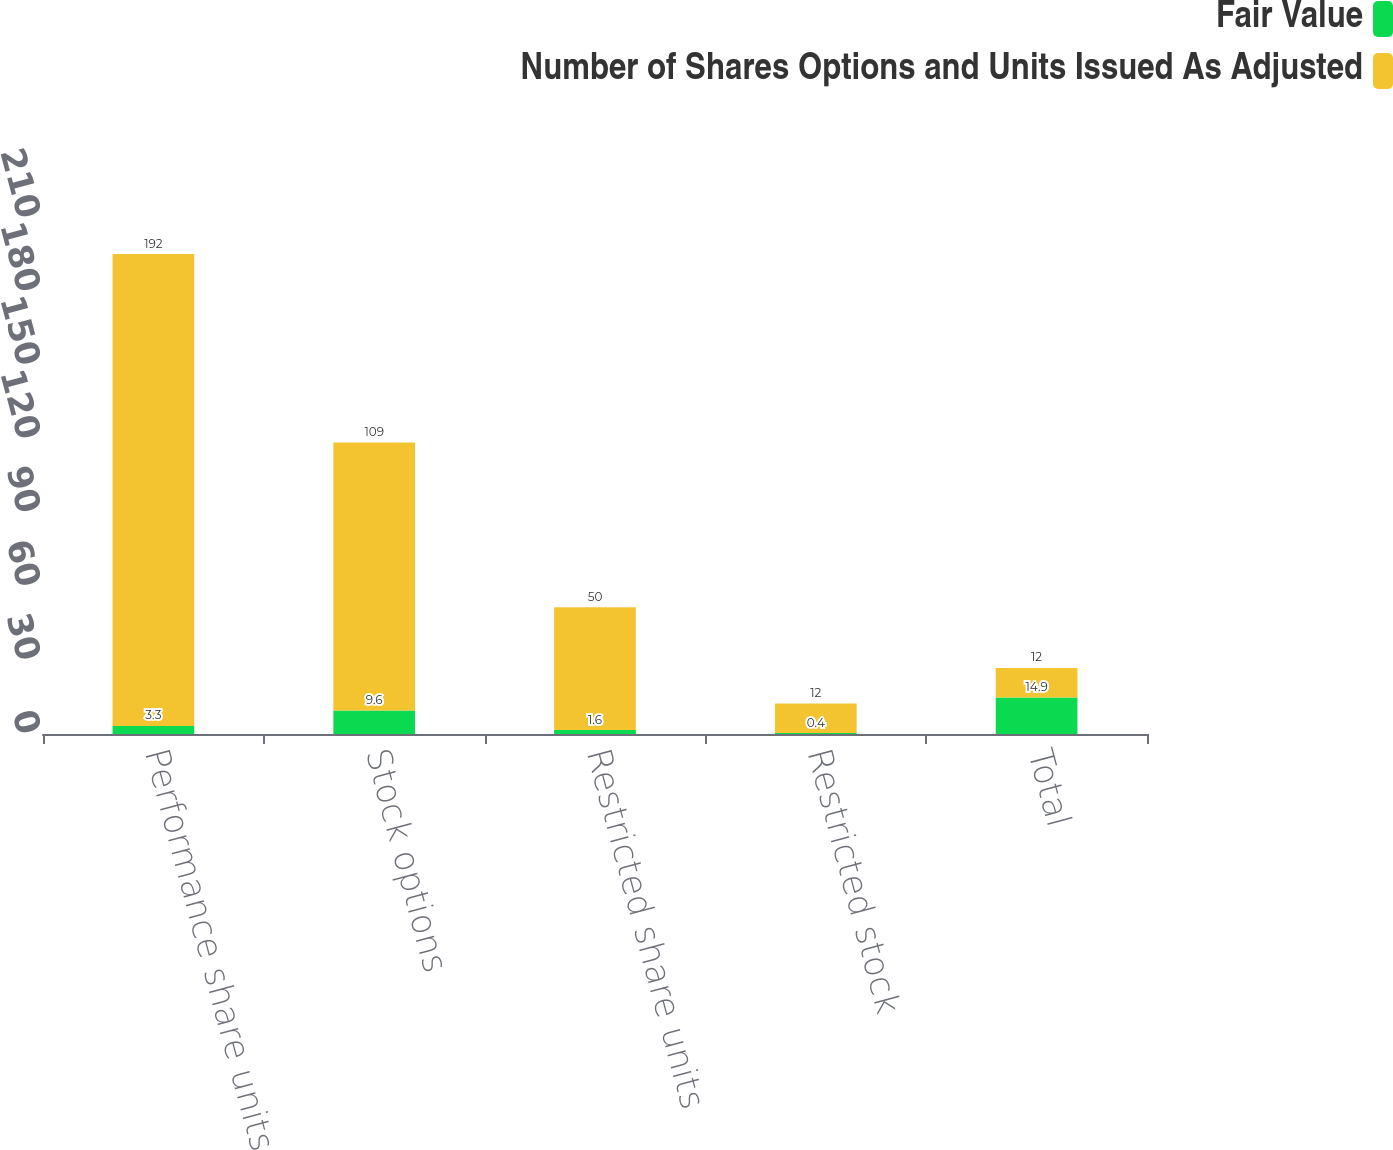Convert chart. <chart><loc_0><loc_0><loc_500><loc_500><stacked_bar_chart><ecel><fcel>Performance share units<fcel>Stock options<fcel>Restricted share units<fcel>Restricted stock<fcel>Total<nl><fcel>Fair Value<fcel>3.3<fcel>9.6<fcel>1.6<fcel>0.4<fcel>14.9<nl><fcel>Number of Shares Options and Units Issued As Adjusted<fcel>192<fcel>109<fcel>50<fcel>12<fcel>12<nl></chart> 